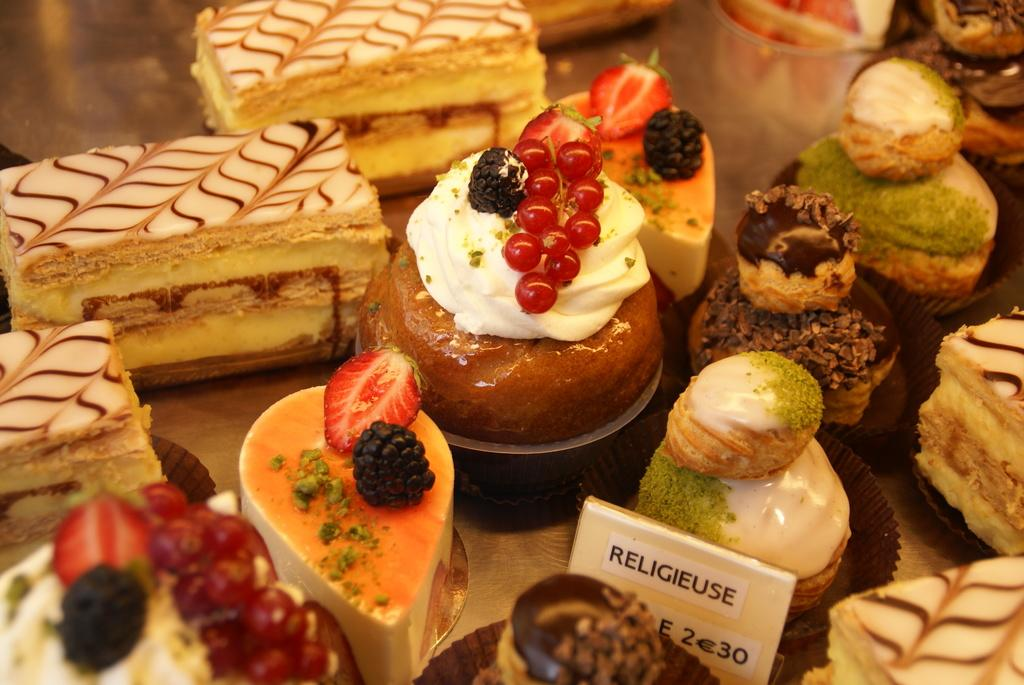What types of baked goods are visible in the image? There are cakes, bread puddings, and pastries in the image. Where are the baked goods likely located in the image? The items are likely on a table. What type of establishment might the image have been taken in? The image may have been taken in a shop. Can you see any crooks in the image? There are no crooks present in the image; it features baked goods on a table. Are there any friends interacting with each other in the image? There is no indication of friends or any social interaction in the image, as it focuses on baked goods on a table. 